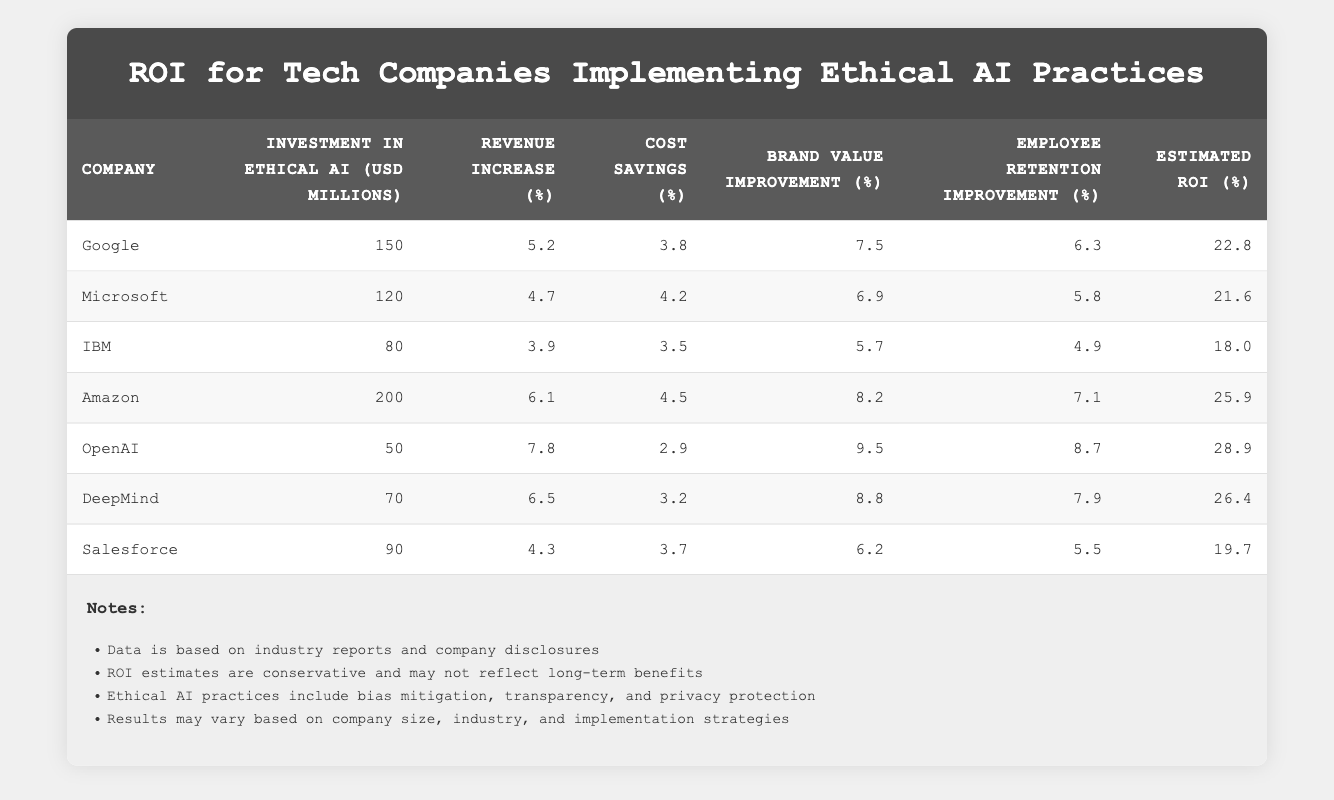What is the estimated ROI for Amazon? The estimated ROI for Amazon is listed in the table as 25.9%.
Answer: 25.9% What company has the highest estimated ROI? By scanning each company's row, OpenAI has the highest estimated ROI of 28.9%.
Answer: 28.9% Is the investment in Ethical AI for Microsoft less than the investment for DeepMind? Microsoft invested 120 million while DeepMind invested 70 million. Since 120 is greater than 70, the statement is false.
Answer: No Calculate the average revenue increase percentage for all listed companies. The revenue increases are: 5.2, 4.7, 3.9, 6.1, 7.8, 6.5, and 4.3. Summing these up gives 38.5. Dividing by 7 (the number of companies) gives an average of approximately 5.5%.
Answer: 5.5% Which company shows the least improvement in employee retention? Looking through the employee retention percentages, IBM has the lowest value at 4.9%.
Answer: 4.9% Is it true that all companies with a higher revenue increase percentage also have a higher estimated ROI? Comparing the revenue increase and ROI percentages, we find that OpenAI has the highest revenue increase of 7.8% but has a lower ROI of 28.9 compared to Amazon’s 6.1% with a higher ROI of 25.9%. Therefore, the statement is false.
Answer: No What is the total investment in Ethical AI for all companies combined? The investments are 150, 120, 80, 200, 50, 70, and 90 million. Adding these together gives 860 million as the total investment.
Answer: 860 million How much brand value improvement percentage did Google achieve? The table states Google's brand value improvement percentage as 7.5%.
Answer: 7.5% Which company has the highest cost savings percentage? Reviewing the cost savings percentages, Microsoft achieved the highest at 4.2%.
Answer: 4.2% 